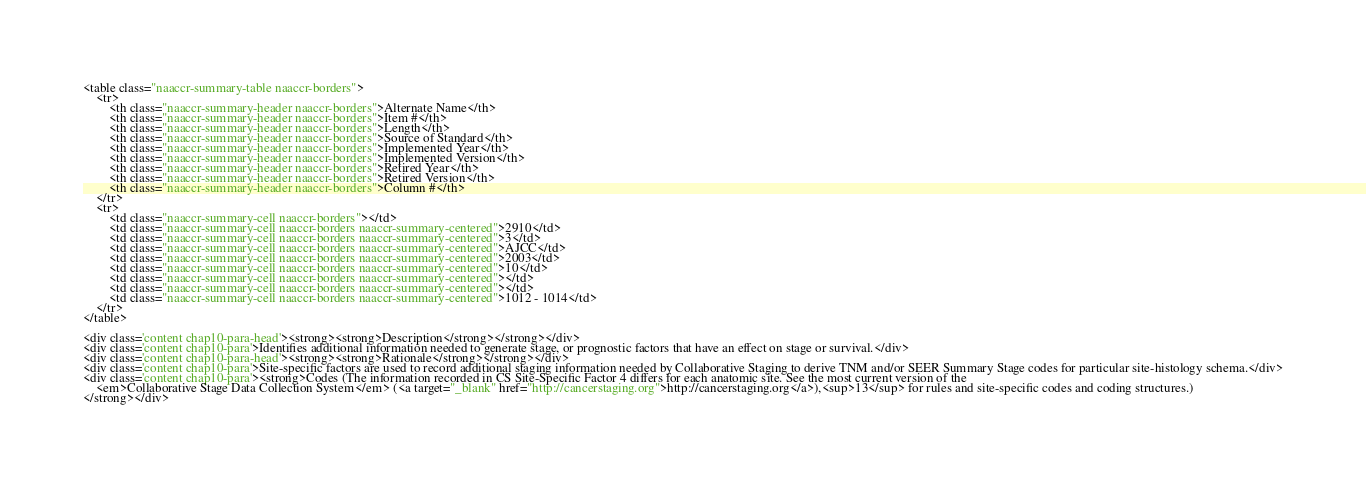<code> <loc_0><loc_0><loc_500><loc_500><_HTML_><table class="naaccr-summary-table naaccr-borders">
    <tr>
        <th class="naaccr-summary-header naaccr-borders">Alternate Name</th>
        <th class="naaccr-summary-header naaccr-borders">Item #</th>
        <th class="naaccr-summary-header naaccr-borders">Length</th>
        <th class="naaccr-summary-header naaccr-borders">Source of Standard</th>
        <th class="naaccr-summary-header naaccr-borders">Implemented Year</th>
        <th class="naaccr-summary-header naaccr-borders">Implemented Version</th>
        <th class="naaccr-summary-header naaccr-borders">Retired Year</th>
        <th class="naaccr-summary-header naaccr-borders">Retired Version</th>
        <th class="naaccr-summary-header naaccr-borders">Column #</th>
    </tr>
    <tr>
        <td class="naaccr-summary-cell naaccr-borders"></td>
        <td class="naaccr-summary-cell naaccr-borders naaccr-summary-centered">2910</td>
        <td class="naaccr-summary-cell naaccr-borders naaccr-summary-centered">3</td>
        <td class="naaccr-summary-cell naaccr-borders naaccr-summary-centered">AJCC</td>
        <td class="naaccr-summary-cell naaccr-borders naaccr-summary-centered">2003</td>
        <td class="naaccr-summary-cell naaccr-borders naaccr-summary-centered">10</td>
        <td class="naaccr-summary-cell naaccr-borders naaccr-summary-centered"></td>
        <td class="naaccr-summary-cell naaccr-borders naaccr-summary-centered"></td>
        <td class="naaccr-summary-cell naaccr-borders naaccr-summary-centered">1012 - 1014</td>
    </tr>
</table>

<div class='content chap10-para-head'><strong><strong>Description</strong></strong></div>
<div class='content chap10-para'>Identifies additional information needed to generate stage, or prognostic factors that have an effect on stage or survival.</div>
<div class='content chap10-para-head'><strong><strong>Rationale</strong></strong></div>
<div class='content chap10-para'>Site-specific factors are used to record additional staging information needed by Collaborative Staging to derive TNM and/or SEER Summary Stage codes for particular site-histology schema.</div>
<div class='content chap10-para'><strong>Codes (The information recorded in CS Site-Specific Factor 4 differs for each anatomic site. See the most current version of the
    <em>Collaborative Stage Data Collection System</em> (<a target="_blank" href="http://cancerstaging.org">http://cancerstaging.org</a>),<sup>13</sup> for rules and site-specific codes and coding structures.)
</strong></div></code> 